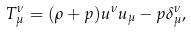Convert formula to latex. <formula><loc_0><loc_0><loc_500><loc_500>T _ { \mu } ^ { \nu } = ( \rho + p ) u ^ { \nu } u _ { \mu } - p \delta _ { \mu } ^ { \nu } ,</formula> 